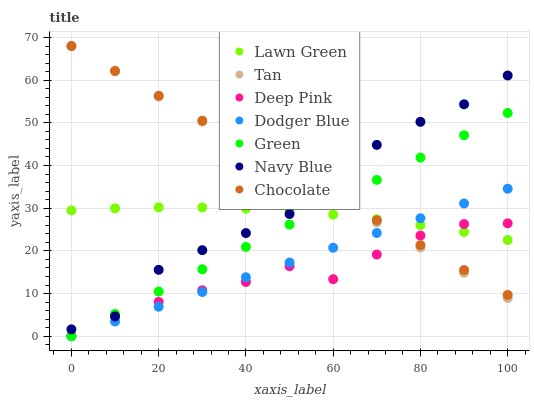Does Deep Pink have the minimum area under the curve?
Answer yes or no. Yes. Does Chocolate have the maximum area under the curve?
Answer yes or no. Yes. Does Navy Blue have the minimum area under the curve?
Answer yes or no. No. Does Navy Blue have the maximum area under the curve?
Answer yes or no. No. Is Dodger Blue the smoothest?
Answer yes or no. Yes. Is Navy Blue the roughest?
Answer yes or no. Yes. Is Deep Pink the smoothest?
Answer yes or no. No. Is Deep Pink the roughest?
Answer yes or no. No. Does Dodger Blue have the lowest value?
Answer yes or no. Yes. Does Deep Pink have the lowest value?
Answer yes or no. No. Does Tan have the highest value?
Answer yes or no. Yes. Does Navy Blue have the highest value?
Answer yes or no. No. Is Dodger Blue less than Navy Blue?
Answer yes or no. Yes. Is Navy Blue greater than Dodger Blue?
Answer yes or no. Yes. Does Green intersect Lawn Green?
Answer yes or no. Yes. Is Green less than Lawn Green?
Answer yes or no. No. Is Green greater than Lawn Green?
Answer yes or no. No. Does Dodger Blue intersect Navy Blue?
Answer yes or no. No. 